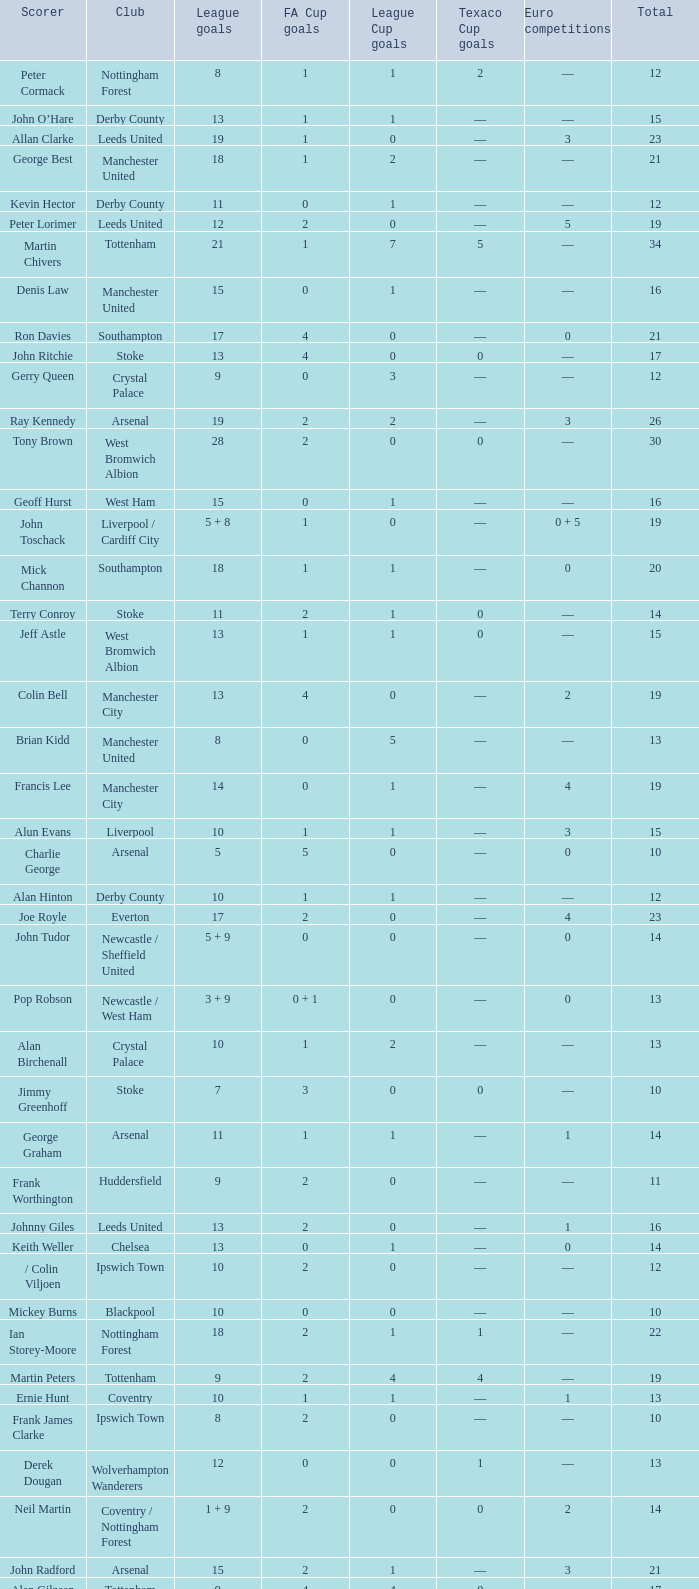What is the typical total, when fa cup goals is 1, when league goals is 10, and when club is crystal palace? 13.0. 